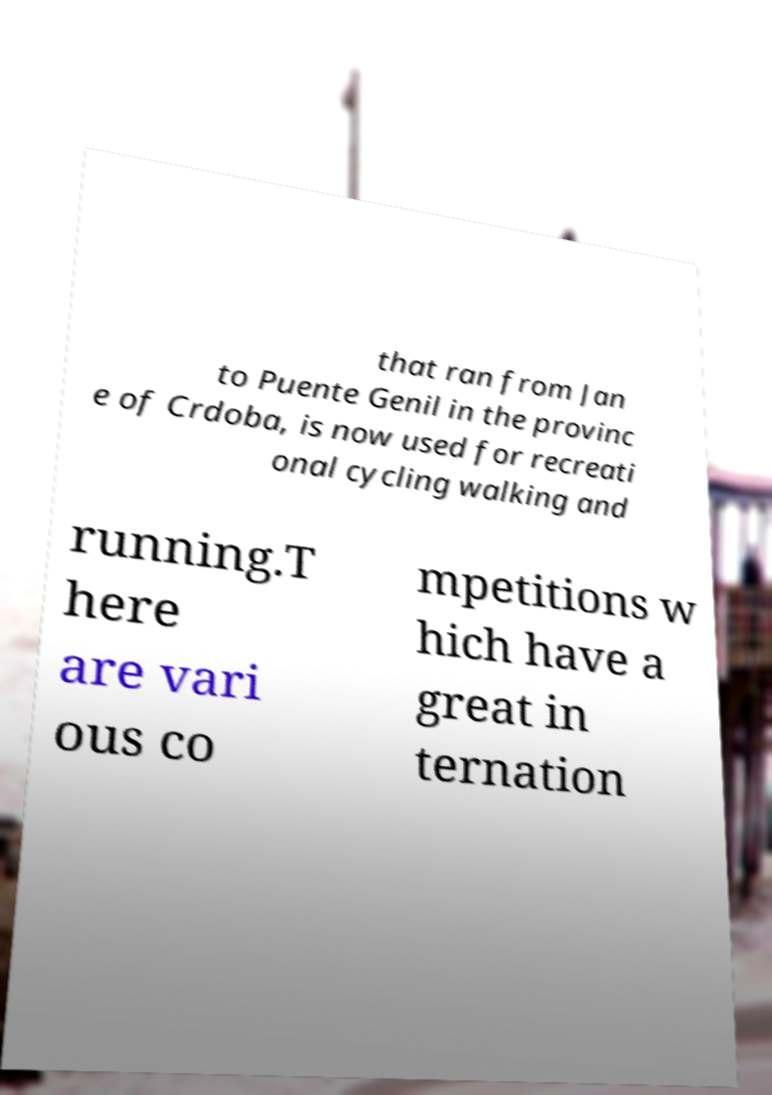Please read and relay the text visible in this image. What does it say? that ran from Jan to Puente Genil in the provinc e of Crdoba, is now used for recreati onal cycling walking and running.T here are vari ous co mpetitions w hich have a great in ternation 